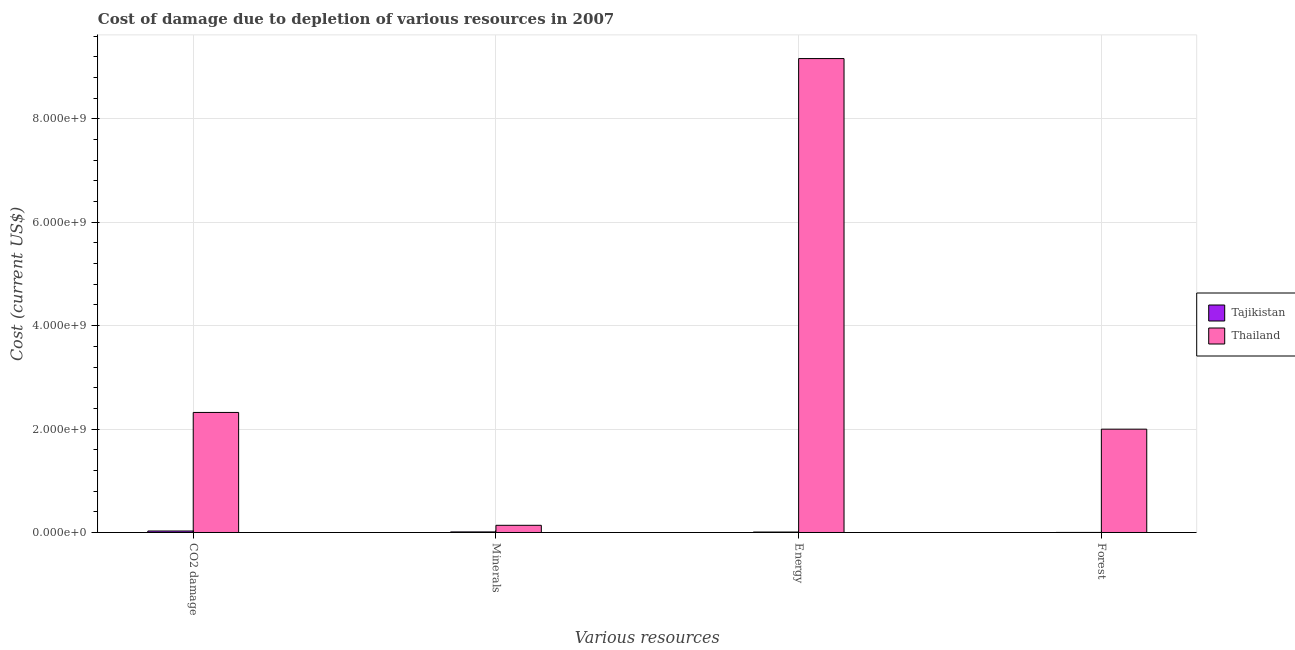How many groups of bars are there?
Your answer should be very brief. 4. What is the label of the 1st group of bars from the left?
Ensure brevity in your answer.  CO2 damage. What is the cost of damage due to depletion of minerals in Tajikistan?
Offer a terse response. 1.12e+07. Across all countries, what is the maximum cost of damage due to depletion of energy?
Keep it short and to the point. 9.17e+09. Across all countries, what is the minimum cost of damage due to depletion of forests?
Ensure brevity in your answer.  1.10e+06. In which country was the cost of damage due to depletion of forests maximum?
Ensure brevity in your answer.  Thailand. In which country was the cost of damage due to depletion of energy minimum?
Your answer should be compact. Tajikistan. What is the total cost of damage due to depletion of minerals in the graph?
Give a very brief answer. 1.50e+08. What is the difference between the cost of damage due to depletion of coal in Tajikistan and that in Thailand?
Your answer should be very brief. -2.29e+09. What is the difference between the cost of damage due to depletion of forests in Thailand and the cost of damage due to depletion of energy in Tajikistan?
Offer a terse response. 1.99e+09. What is the average cost of damage due to depletion of forests per country?
Your answer should be very brief. 1.00e+09. What is the difference between the cost of damage due to depletion of forests and cost of damage due to depletion of energy in Tajikistan?
Your answer should be very brief. -7.43e+06. What is the ratio of the cost of damage due to depletion of coal in Thailand to that in Tajikistan?
Your answer should be compact. 80.58. Is the difference between the cost of damage due to depletion of coal in Thailand and Tajikistan greater than the difference between the cost of damage due to depletion of minerals in Thailand and Tajikistan?
Offer a very short reply. Yes. What is the difference between the highest and the second highest cost of damage due to depletion of coal?
Give a very brief answer. 2.29e+09. What is the difference between the highest and the lowest cost of damage due to depletion of coal?
Give a very brief answer. 2.29e+09. What does the 1st bar from the left in CO2 damage represents?
Offer a very short reply. Tajikistan. What does the 1st bar from the right in Minerals represents?
Keep it short and to the point. Thailand. Is it the case that in every country, the sum of the cost of damage due to depletion of coal and cost of damage due to depletion of minerals is greater than the cost of damage due to depletion of energy?
Provide a succinct answer. No. How many countries are there in the graph?
Make the answer very short. 2. Are the values on the major ticks of Y-axis written in scientific E-notation?
Your response must be concise. Yes. How many legend labels are there?
Keep it short and to the point. 2. What is the title of the graph?
Offer a terse response. Cost of damage due to depletion of various resources in 2007 . Does "Small states" appear as one of the legend labels in the graph?
Offer a very short reply. No. What is the label or title of the X-axis?
Make the answer very short. Various resources. What is the label or title of the Y-axis?
Your response must be concise. Cost (current US$). What is the Cost (current US$) of Tajikistan in CO2 damage?
Offer a very short reply. 2.88e+07. What is the Cost (current US$) of Thailand in CO2 damage?
Ensure brevity in your answer.  2.32e+09. What is the Cost (current US$) of Tajikistan in Minerals?
Offer a very short reply. 1.12e+07. What is the Cost (current US$) in Thailand in Minerals?
Make the answer very short. 1.39e+08. What is the Cost (current US$) in Tajikistan in Energy?
Offer a very short reply. 8.52e+06. What is the Cost (current US$) of Thailand in Energy?
Provide a succinct answer. 9.17e+09. What is the Cost (current US$) of Tajikistan in Forest?
Your answer should be compact. 1.10e+06. What is the Cost (current US$) of Thailand in Forest?
Provide a succinct answer. 2.00e+09. Across all Various resources, what is the maximum Cost (current US$) in Tajikistan?
Ensure brevity in your answer.  2.88e+07. Across all Various resources, what is the maximum Cost (current US$) in Thailand?
Give a very brief answer. 9.17e+09. Across all Various resources, what is the minimum Cost (current US$) in Tajikistan?
Give a very brief answer. 1.10e+06. Across all Various resources, what is the minimum Cost (current US$) in Thailand?
Your answer should be compact. 1.39e+08. What is the total Cost (current US$) in Tajikistan in the graph?
Provide a short and direct response. 4.96e+07. What is the total Cost (current US$) of Thailand in the graph?
Keep it short and to the point. 1.36e+1. What is the difference between the Cost (current US$) in Tajikistan in CO2 damage and that in Minerals?
Your response must be concise. 1.76e+07. What is the difference between the Cost (current US$) of Thailand in CO2 damage and that in Minerals?
Ensure brevity in your answer.  2.18e+09. What is the difference between the Cost (current US$) of Tajikistan in CO2 damage and that in Energy?
Your answer should be very brief. 2.03e+07. What is the difference between the Cost (current US$) of Thailand in CO2 damage and that in Energy?
Provide a short and direct response. -6.84e+09. What is the difference between the Cost (current US$) of Tajikistan in CO2 damage and that in Forest?
Offer a very short reply. 2.77e+07. What is the difference between the Cost (current US$) of Thailand in CO2 damage and that in Forest?
Provide a succinct answer. 3.23e+08. What is the difference between the Cost (current US$) in Tajikistan in Minerals and that in Energy?
Ensure brevity in your answer.  2.69e+06. What is the difference between the Cost (current US$) in Thailand in Minerals and that in Energy?
Your answer should be compact. -9.03e+09. What is the difference between the Cost (current US$) of Tajikistan in Minerals and that in Forest?
Provide a short and direct response. 1.01e+07. What is the difference between the Cost (current US$) of Thailand in Minerals and that in Forest?
Your answer should be very brief. -1.86e+09. What is the difference between the Cost (current US$) of Tajikistan in Energy and that in Forest?
Make the answer very short. 7.43e+06. What is the difference between the Cost (current US$) in Thailand in Energy and that in Forest?
Make the answer very short. 7.17e+09. What is the difference between the Cost (current US$) in Tajikistan in CO2 damage and the Cost (current US$) in Thailand in Minerals?
Your answer should be very brief. -1.10e+08. What is the difference between the Cost (current US$) in Tajikistan in CO2 damage and the Cost (current US$) in Thailand in Energy?
Your answer should be very brief. -9.14e+09. What is the difference between the Cost (current US$) of Tajikistan in CO2 damage and the Cost (current US$) of Thailand in Forest?
Give a very brief answer. -1.97e+09. What is the difference between the Cost (current US$) of Tajikistan in Minerals and the Cost (current US$) of Thailand in Energy?
Offer a terse response. -9.15e+09. What is the difference between the Cost (current US$) of Tajikistan in Minerals and the Cost (current US$) of Thailand in Forest?
Keep it short and to the point. -1.99e+09. What is the difference between the Cost (current US$) of Tajikistan in Energy and the Cost (current US$) of Thailand in Forest?
Ensure brevity in your answer.  -1.99e+09. What is the average Cost (current US$) of Tajikistan per Various resources?
Your answer should be very brief. 1.24e+07. What is the average Cost (current US$) of Thailand per Various resources?
Provide a succinct answer. 3.41e+09. What is the difference between the Cost (current US$) in Tajikistan and Cost (current US$) in Thailand in CO2 damage?
Make the answer very short. -2.29e+09. What is the difference between the Cost (current US$) of Tajikistan and Cost (current US$) of Thailand in Minerals?
Offer a terse response. -1.28e+08. What is the difference between the Cost (current US$) in Tajikistan and Cost (current US$) in Thailand in Energy?
Make the answer very short. -9.16e+09. What is the difference between the Cost (current US$) in Tajikistan and Cost (current US$) in Thailand in Forest?
Your answer should be very brief. -2.00e+09. What is the ratio of the Cost (current US$) in Tajikistan in CO2 damage to that in Minerals?
Your response must be concise. 2.57. What is the ratio of the Cost (current US$) in Thailand in CO2 damage to that in Minerals?
Keep it short and to the point. 16.72. What is the ratio of the Cost (current US$) of Tajikistan in CO2 damage to that in Energy?
Your answer should be very brief. 3.38. What is the ratio of the Cost (current US$) in Thailand in CO2 damage to that in Energy?
Offer a very short reply. 0.25. What is the ratio of the Cost (current US$) of Tajikistan in CO2 damage to that in Forest?
Provide a succinct answer. 26.27. What is the ratio of the Cost (current US$) of Thailand in CO2 damage to that in Forest?
Your answer should be very brief. 1.16. What is the ratio of the Cost (current US$) in Tajikistan in Minerals to that in Energy?
Your answer should be very brief. 1.32. What is the ratio of the Cost (current US$) in Thailand in Minerals to that in Energy?
Offer a terse response. 0.02. What is the ratio of the Cost (current US$) of Tajikistan in Minerals to that in Forest?
Ensure brevity in your answer.  10.23. What is the ratio of the Cost (current US$) of Thailand in Minerals to that in Forest?
Ensure brevity in your answer.  0.07. What is the ratio of the Cost (current US$) in Tajikistan in Energy to that in Forest?
Ensure brevity in your answer.  7.77. What is the ratio of the Cost (current US$) in Thailand in Energy to that in Forest?
Your response must be concise. 4.59. What is the difference between the highest and the second highest Cost (current US$) in Tajikistan?
Your answer should be compact. 1.76e+07. What is the difference between the highest and the second highest Cost (current US$) of Thailand?
Your response must be concise. 6.84e+09. What is the difference between the highest and the lowest Cost (current US$) of Tajikistan?
Make the answer very short. 2.77e+07. What is the difference between the highest and the lowest Cost (current US$) in Thailand?
Keep it short and to the point. 9.03e+09. 